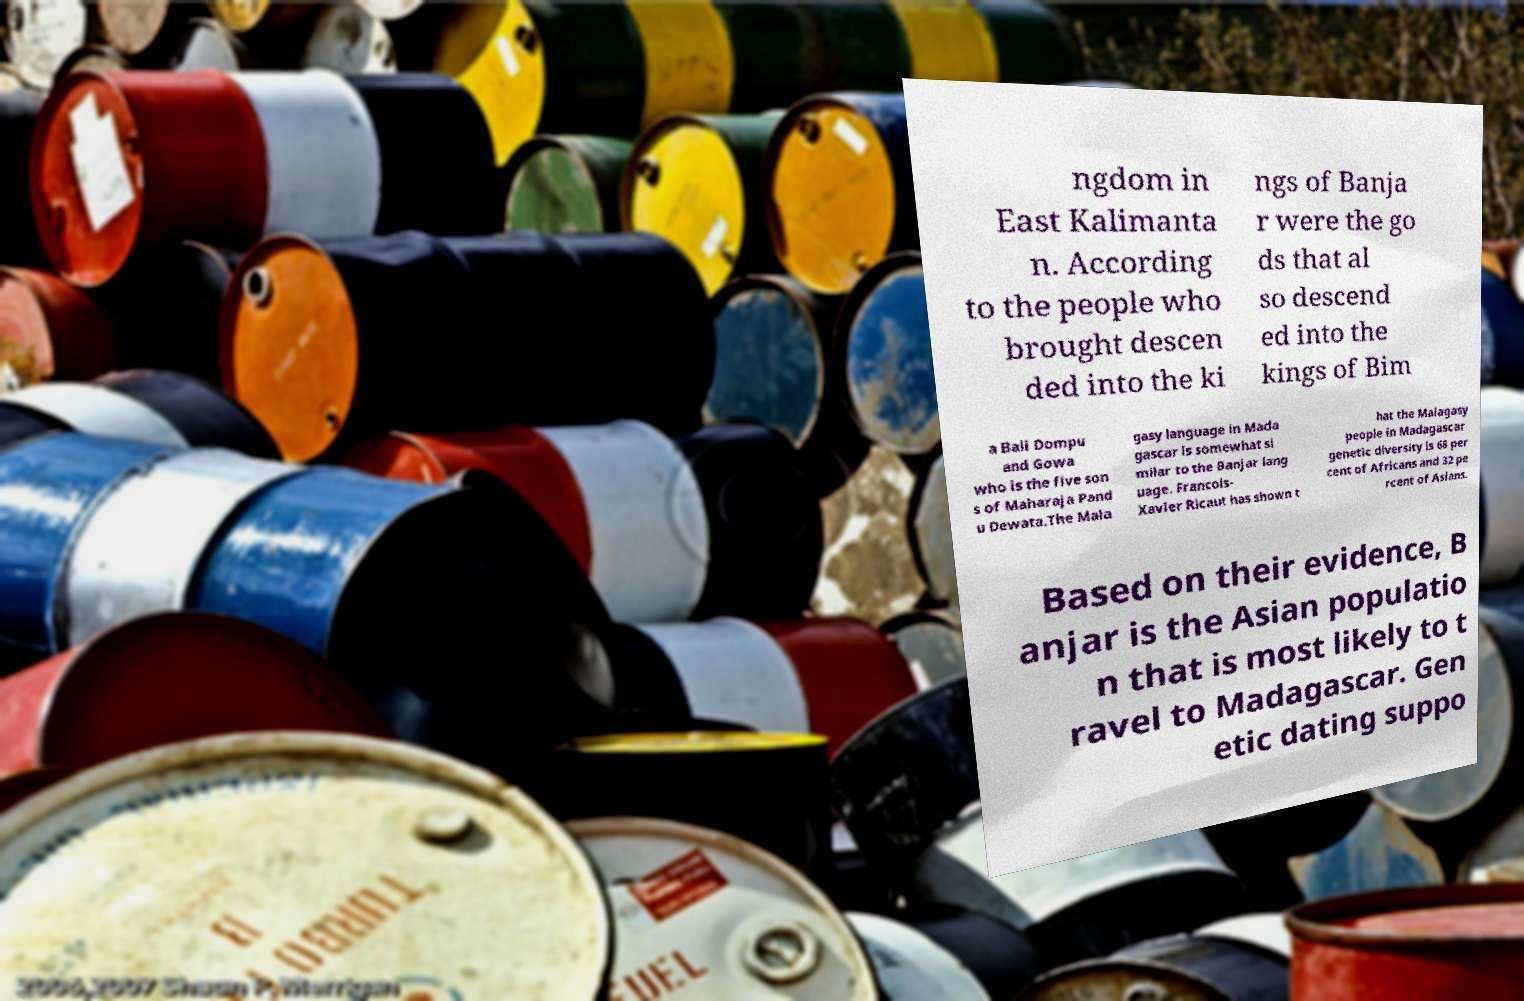What messages or text are displayed in this image? I need them in a readable, typed format. ngdom in East Kalimanta n. According to the people who brought descen ded into the ki ngs of Banja r were the go ds that al so descend ed into the kings of Bim a Bali Dompu and Gowa who is the five son s of Maharaja Pand u Dewata.The Mala gasy language in Mada gascar is somewhat si milar to the Banjar lang uage. Francois- Xavier Ricaut has shown t hat the Malagasy people in Madagascar genetic diversity is 68 per cent of Africans and 32 pe rcent of Asians. Based on their evidence, B anjar is the Asian populatio n that is most likely to t ravel to Madagascar. Gen etic dating suppo 